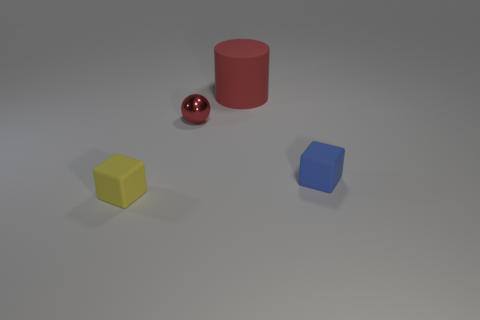What materials do the objects seem to be made from? The red object appears to be a shiny metallic ball, the yellow and blue objects look like they're made of a matte plastic material, and the oversized red shape seems to be a metallic cylinder. 